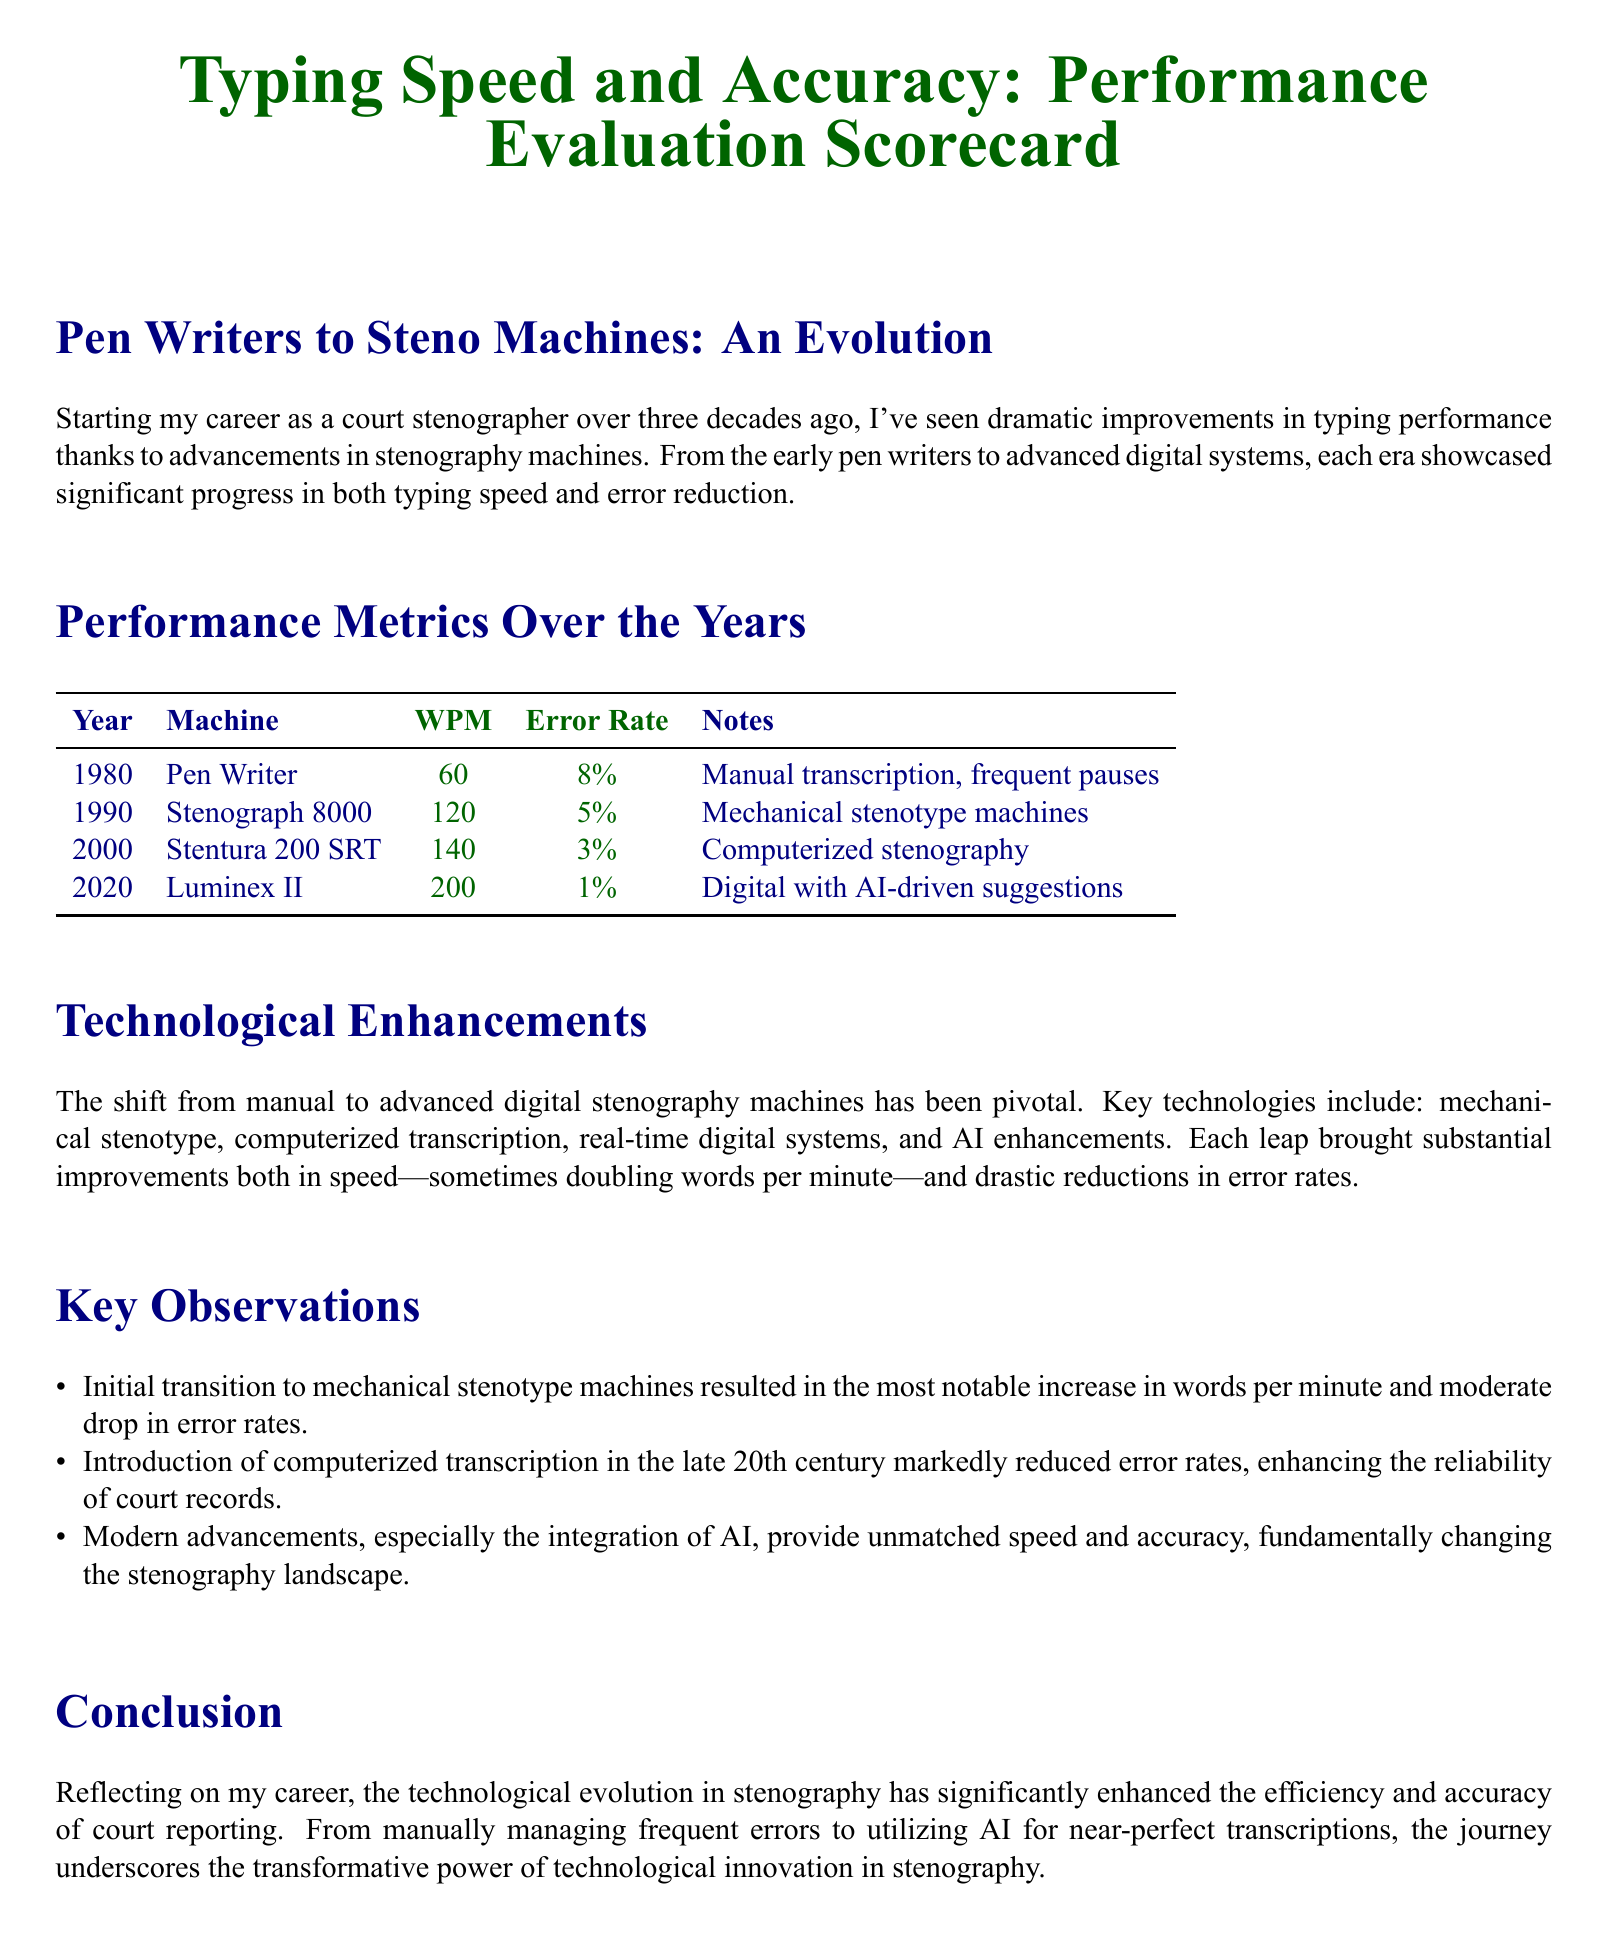What was the WPM in 1980? The WPM in 1980 is listed in the performance metrics table under that year, which is 60.
Answer: 60 What machine was used in 1990? The machine used in 1990 is specified in the table, which is Stenograph 8000.
Answer: Stenograph 8000 What was the error rate in 2020? The error rate in 2020 is noted in the performance metrics table, which is 1%.
Answer: 1% Which technological advancement resulted in a notable increase in speed? The document indicates that the introduction of mechanical stenotype machines resulted in the most notable increase in speed.
Answer: Mechanical stenotype What is the maximum WPM achieved according to the scorecard? The maximum WPM achieved is detailed in the performance metrics table, which is 200.
Answer: 200 How much did the error rate decrease from 1980 to 2020? The error rate decreased from 8% in 1980 to 1% in 2020, which is a decrease of 7 percentage points.
Answer: 7 percentage points What is the primary benefit of AI enhancements in modern stenography? The document states that modern advancements, especially AI, provide unmatched speed and accuracy.
Answer: Unmatched speed and accuracy What year marks the transition to computerized transcription? The transition to computerized transcription is first mentioned for the year 2000 in the document.
Answer: 2000 What era showcases significant progress in typing performance? The era from the early pen writers to advanced digital systems showcases significant progress, as mentioned in the introduction.
Answer: Early pen writers to advanced digital systems 